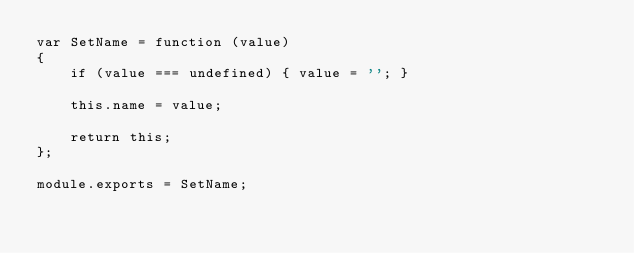<code> <loc_0><loc_0><loc_500><loc_500><_JavaScript_>var SetName = function (value)
{
    if (value === undefined) { value = ''; }

    this.name = value;

    return this;
};

module.exports = SetName;
</code> 